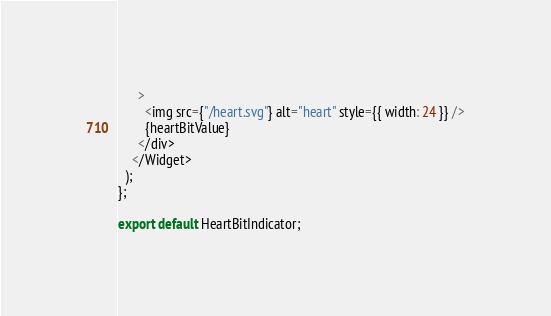<code> <loc_0><loc_0><loc_500><loc_500><_TypeScript_>      >
        <img src={"/heart.svg"} alt="heart" style={{ width: 24 }} />
        {heartBitValue}
      </div>
    </Widget>
  );
};

export default HeartBitIndicator;
</code> 